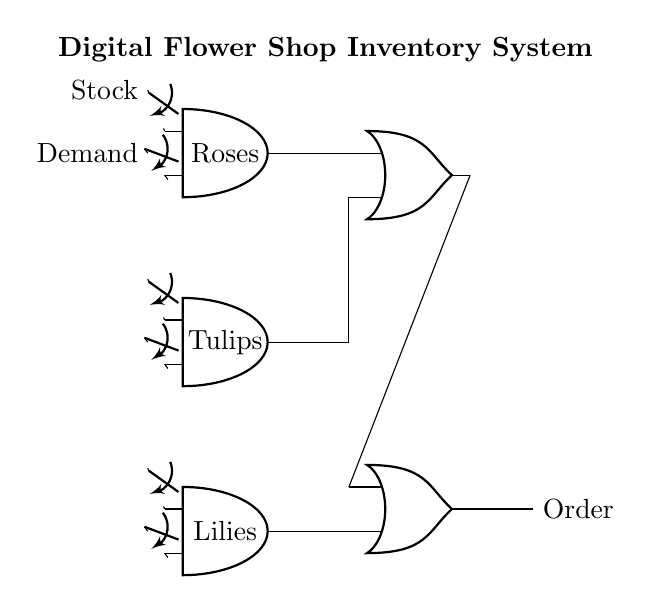What are the types of flowers represented in the circuit? The circuit represents three types of flowers: Roses, Tulips, and Lilies, depicted at the respective AND gate ports.
Answer: Roses, Tulips, Lilies What does the output lead to in this circuit? The output from the OR gates leads to the Order node, indicating successful handling of supplied flower types based on stocks and demands.
Answer: Order How many AND gates are present in the circuit? There are three AND gates in the circuit, each corresponding to a different type of flower.
Answer: Three What controls the flow of data to each AND gate? The flow of data to each AND gate is controlled by two switches: one for stock and one for demand, located before each AND gate.
Answer: Two switches If all AND gates receive input, what will be the output? If all AND gates receive input (stock and demand are both present), the output of the circuit will be activated, resulting in an order being placed.
Answer: Activated What is the function of the OR gates in this circuit? The OR gates combine the outputs of the AND gates; if any of the AND gates output a signal, the OR gates will output an order signal, indicating that at least one flower type can be ordered.
Answer: Combine outputs 